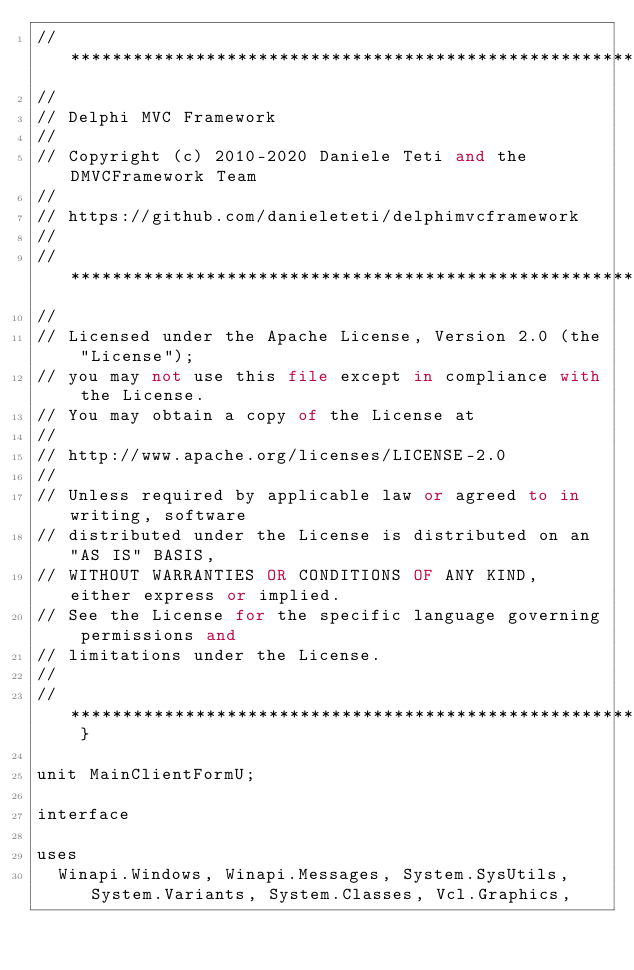<code> <loc_0><loc_0><loc_500><loc_500><_Pascal_>// ***************************************************************************
//
// Delphi MVC Framework
//
// Copyright (c) 2010-2020 Daniele Teti and the DMVCFramework Team
//
// https://github.com/danieleteti/delphimvcframework
//
// ***************************************************************************
//
// Licensed under the Apache License, Version 2.0 (the "License");
// you may not use this file except in compliance with the License.
// You may obtain a copy of the License at
//
// http://www.apache.org/licenses/LICENSE-2.0
//
// Unless required by applicable law or agreed to in writing, software
// distributed under the License is distributed on an "AS IS" BASIS,
// WITHOUT WARRANTIES OR CONDITIONS OF ANY KIND, either express or implied.
// See the License for the specific language governing permissions and
// limitations under the License.
//
// *************************************************************************** }

unit MainClientFormU;

interface

uses
  Winapi.Windows, Winapi.Messages, System.SysUtils, System.Variants, System.Classes, Vcl.Graphics,</code> 